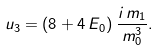Convert formula to latex. <formula><loc_0><loc_0><loc_500><loc_500>u _ { 3 } = ( 8 + 4 \, E _ { 0 } ) \, \frac { i \, m _ { 1 } } { m _ { 0 } ^ { 3 } } .</formula> 